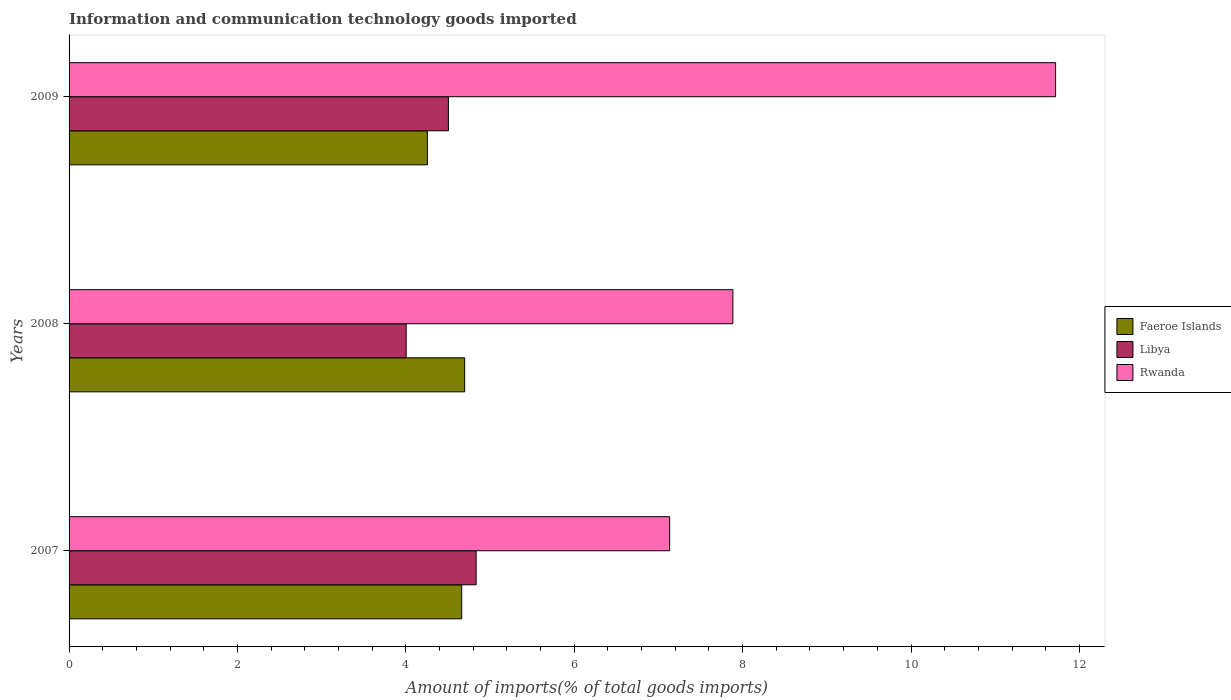How many different coloured bars are there?
Your answer should be compact. 3. How many groups of bars are there?
Make the answer very short. 3. What is the label of the 3rd group of bars from the top?
Your response must be concise. 2007. In how many cases, is the number of bars for a given year not equal to the number of legend labels?
Ensure brevity in your answer.  0. What is the amount of goods imported in Libya in 2008?
Give a very brief answer. 4. Across all years, what is the maximum amount of goods imported in Libya?
Provide a succinct answer. 4.83. Across all years, what is the minimum amount of goods imported in Libya?
Your answer should be compact. 4. In which year was the amount of goods imported in Faeroe Islands maximum?
Offer a terse response. 2008. In which year was the amount of goods imported in Faeroe Islands minimum?
Make the answer very short. 2009. What is the total amount of goods imported in Libya in the graph?
Offer a very short reply. 13.34. What is the difference between the amount of goods imported in Libya in 2007 and that in 2009?
Provide a succinct answer. 0.33. What is the difference between the amount of goods imported in Rwanda in 2009 and the amount of goods imported in Faeroe Islands in 2008?
Provide a short and direct response. 7.02. What is the average amount of goods imported in Rwanda per year?
Make the answer very short. 8.91. In the year 2007, what is the difference between the amount of goods imported in Libya and amount of goods imported in Rwanda?
Your answer should be compact. -2.3. What is the ratio of the amount of goods imported in Libya in 2007 to that in 2009?
Give a very brief answer. 1.07. Is the difference between the amount of goods imported in Libya in 2008 and 2009 greater than the difference between the amount of goods imported in Rwanda in 2008 and 2009?
Your answer should be very brief. Yes. What is the difference between the highest and the second highest amount of goods imported in Faeroe Islands?
Ensure brevity in your answer.  0.04. What is the difference between the highest and the lowest amount of goods imported in Rwanda?
Keep it short and to the point. 4.58. In how many years, is the amount of goods imported in Faeroe Islands greater than the average amount of goods imported in Faeroe Islands taken over all years?
Give a very brief answer. 2. What does the 2nd bar from the top in 2009 represents?
Ensure brevity in your answer.  Libya. What does the 2nd bar from the bottom in 2008 represents?
Offer a terse response. Libya. Is it the case that in every year, the sum of the amount of goods imported in Faeroe Islands and amount of goods imported in Libya is greater than the amount of goods imported in Rwanda?
Give a very brief answer. No. How many bars are there?
Your response must be concise. 9. Are all the bars in the graph horizontal?
Provide a succinct answer. Yes. How many years are there in the graph?
Your answer should be compact. 3. What is the difference between two consecutive major ticks on the X-axis?
Your answer should be very brief. 2. Are the values on the major ticks of X-axis written in scientific E-notation?
Your answer should be very brief. No. Does the graph contain any zero values?
Provide a succinct answer. No. What is the title of the graph?
Offer a very short reply. Information and communication technology goods imported. Does "Tonga" appear as one of the legend labels in the graph?
Ensure brevity in your answer.  No. What is the label or title of the X-axis?
Offer a terse response. Amount of imports(% of total goods imports). What is the label or title of the Y-axis?
Offer a very short reply. Years. What is the Amount of imports(% of total goods imports) in Faeroe Islands in 2007?
Provide a succinct answer. 4.66. What is the Amount of imports(% of total goods imports) of Libya in 2007?
Your answer should be compact. 4.83. What is the Amount of imports(% of total goods imports) of Rwanda in 2007?
Your answer should be very brief. 7.13. What is the Amount of imports(% of total goods imports) in Faeroe Islands in 2008?
Your answer should be very brief. 4.7. What is the Amount of imports(% of total goods imports) of Libya in 2008?
Provide a succinct answer. 4. What is the Amount of imports(% of total goods imports) in Rwanda in 2008?
Offer a terse response. 7.88. What is the Amount of imports(% of total goods imports) in Faeroe Islands in 2009?
Offer a very short reply. 4.26. What is the Amount of imports(% of total goods imports) in Libya in 2009?
Your answer should be compact. 4.51. What is the Amount of imports(% of total goods imports) of Rwanda in 2009?
Make the answer very short. 11.72. Across all years, what is the maximum Amount of imports(% of total goods imports) of Faeroe Islands?
Provide a succinct answer. 4.7. Across all years, what is the maximum Amount of imports(% of total goods imports) in Libya?
Offer a terse response. 4.83. Across all years, what is the maximum Amount of imports(% of total goods imports) of Rwanda?
Ensure brevity in your answer.  11.72. Across all years, what is the minimum Amount of imports(% of total goods imports) of Faeroe Islands?
Make the answer very short. 4.26. Across all years, what is the minimum Amount of imports(% of total goods imports) in Libya?
Ensure brevity in your answer.  4. Across all years, what is the minimum Amount of imports(% of total goods imports) of Rwanda?
Ensure brevity in your answer.  7.13. What is the total Amount of imports(% of total goods imports) of Faeroe Islands in the graph?
Your response must be concise. 13.62. What is the total Amount of imports(% of total goods imports) of Libya in the graph?
Keep it short and to the point. 13.34. What is the total Amount of imports(% of total goods imports) of Rwanda in the graph?
Your response must be concise. 26.73. What is the difference between the Amount of imports(% of total goods imports) in Faeroe Islands in 2007 and that in 2008?
Ensure brevity in your answer.  -0.04. What is the difference between the Amount of imports(% of total goods imports) of Libya in 2007 and that in 2008?
Make the answer very short. 0.83. What is the difference between the Amount of imports(% of total goods imports) in Rwanda in 2007 and that in 2008?
Make the answer very short. -0.75. What is the difference between the Amount of imports(% of total goods imports) of Faeroe Islands in 2007 and that in 2009?
Your answer should be compact. 0.41. What is the difference between the Amount of imports(% of total goods imports) in Libya in 2007 and that in 2009?
Provide a short and direct response. 0.33. What is the difference between the Amount of imports(% of total goods imports) of Rwanda in 2007 and that in 2009?
Ensure brevity in your answer.  -4.58. What is the difference between the Amount of imports(% of total goods imports) of Faeroe Islands in 2008 and that in 2009?
Offer a terse response. 0.44. What is the difference between the Amount of imports(% of total goods imports) in Libya in 2008 and that in 2009?
Your response must be concise. -0.5. What is the difference between the Amount of imports(% of total goods imports) of Rwanda in 2008 and that in 2009?
Your answer should be very brief. -3.83. What is the difference between the Amount of imports(% of total goods imports) of Faeroe Islands in 2007 and the Amount of imports(% of total goods imports) of Libya in 2008?
Give a very brief answer. 0.66. What is the difference between the Amount of imports(% of total goods imports) in Faeroe Islands in 2007 and the Amount of imports(% of total goods imports) in Rwanda in 2008?
Your answer should be very brief. -3.22. What is the difference between the Amount of imports(% of total goods imports) in Libya in 2007 and the Amount of imports(% of total goods imports) in Rwanda in 2008?
Your answer should be very brief. -3.05. What is the difference between the Amount of imports(% of total goods imports) of Faeroe Islands in 2007 and the Amount of imports(% of total goods imports) of Libya in 2009?
Your response must be concise. 0.16. What is the difference between the Amount of imports(% of total goods imports) of Faeroe Islands in 2007 and the Amount of imports(% of total goods imports) of Rwanda in 2009?
Offer a very short reply. -7.05. What is the difference between the Amount of imports(% of total goods imports) in Libya in 2007 and the Amount of imports(% of total goods imports) in Rwanda in 2009?
Give a very brief answer. -6.88. What is the difference between the Amount of imports(% of total goods imports) of Faeroe Islands in 2008 and the Amount of imports(% of total goods imports) of Libya in 2009?
Give a very brief answer. 0.19. What is the difference between the Amount of imports(% of total goods imports) of Faeroe Islands in 2008 and the Amount of imports(% of total goods imports) of Rwanda in 2009?
Provide a succinct answer. -7.02. What is the difference between the Amount of imports(% of total goods imports) of Libya in 2008 and the Amount of imports(% of total goods imports) of Rwanda in 2009?
Provide a short and direct response. -7.71. What is the average Amount of imports(% of total goods imports) of Faeroe Islands per year?
Your answer should be compact. 4.54. What is the average Amount of imports(% of total goods imports) in Libya per year?
Make the answer very short. 4.45. What is the average Amount of imports(% of total goods imports) of Rwanda per year?
Your answer should be very brief. 8.91. In the year 2007, what is the difference between the Amount of imports(% of total goods imports) in Faeroe Islands and Amount of imports(% of total goods imports) in Libya?
Your answer should be very brief. -0.17. In the year 2007, what is the difference between the Amount of imports(% of total goods imports) in Faeroe Islands and Amount of imports(% of total goods imports) in Rwanda?
Give a very brief answer. -2.47. In the year 2007, what is the difference between the Amount of imports(% of total goods imports) of Libya and Amount of imports(% of total goods imports) of Rwanda?
Offer a terse response. -2.3. In the year 2008, what is the difference between the Amount of imports(% of total goods imports) of Faeroe Islands and Amount of imports(% of total goods imports) of Libya?
Offer a terse response. 0.69. In the year 2008, what is the difference between the Amount of imports(% of total goods imports) in Faeroe Islands and Amount of imports(% of total goods imports) in Rwanda?
Your answer should be compact. -3.19. In the year 2008, what is the difference between the Amount of imports(% of total goods imports) of Libya and Amount of imports(% of total goods imports) of Rwanda?
Offer a terse response. -3.88. In the year 2009, what is the difference between the Amount of imports(% of total goods imports) in Faeroe Islands and Amount of imports(% of total goods imports) in Libya?
Provide a succinct answer. -0.25. In the year 2009, what is the difference between the Amount of imports(% of total goods imports) of Faeroe Islands and Amount of imports(% of total goods imports) of Rwanda?
Offer a very short reply. -7.46. In the year 2009, what is the difference between the Amount of imports(% of total goods imports) in Libya and Amount of imports(% of total goods imports) in Rwanda?
Ensure brevity in your answer.  -7.21. What is the ratio of the Amount of imports(% of total goods imports) in Libya in 2007 to that in 2008?
Give a very brief answer. 1.21. What is the ratio of the Amount of imports(% of total goods imports) of Rwanda in 2007 to that in 2008?
Offer a very short reply. 0.9. What is the ratio of the Amount of imports(% of total goods imports) in Faeroe Islands in 2007 to that in 2009?
Make the answer very short. 1.1. What is the ratio of the Amount of imports(% of total goods imports) in Libya in 2007 to that in 2009?
Give a very brief answer. 1.07. What is the ratio of the Amount of imports(% of total goods imports) in Rwanda in 2007 to that in 2009?
Your answer should be compact. 0.61. What is the ratio of the Amount of imports(% of total goods imports) in Faeroe Islands in 2008 to that in 2009?
Your answer should be very brief. 1.1. What is the ratio of the Amount of imports(% of total goods imports) in Libya in 2008 to that in 2009?
Provide a succinct answer. 0.89. What is the ratio of the Amount of imports(% of total goods imports) in Rwanda in 2008 to that in 2009?
Offer a very short reply. 0.67. What is the difference between the highest and the second highest Amount of imports(% of total goods imports) in Faeroe Islands?
Make the answer very short. 0.04. What is the difference between the highest and the second highest Amount of imports(% of total goods imports) in Libya?
Provide a short and direct response. 0.33. What is the difference between the highest and the second highest Amount of imports(% of total goods imports) of Rwanda?
Your response must be concise. 3.83. What is the difference between the highest and the lowest Amount of imports(% of total goods imports) in Faeroe Islands?
Keep it short and to the point. 0.44. What is the difference between the highest and the lowest Amount of imports(% of total goods imports) in Libya?
Give a very brief answer. 0.83. What is the difference between the highest and the lowest Amount of imports(% of total goods imports) in Rwanda?
Ensure brevity in your answer.  4.58. 